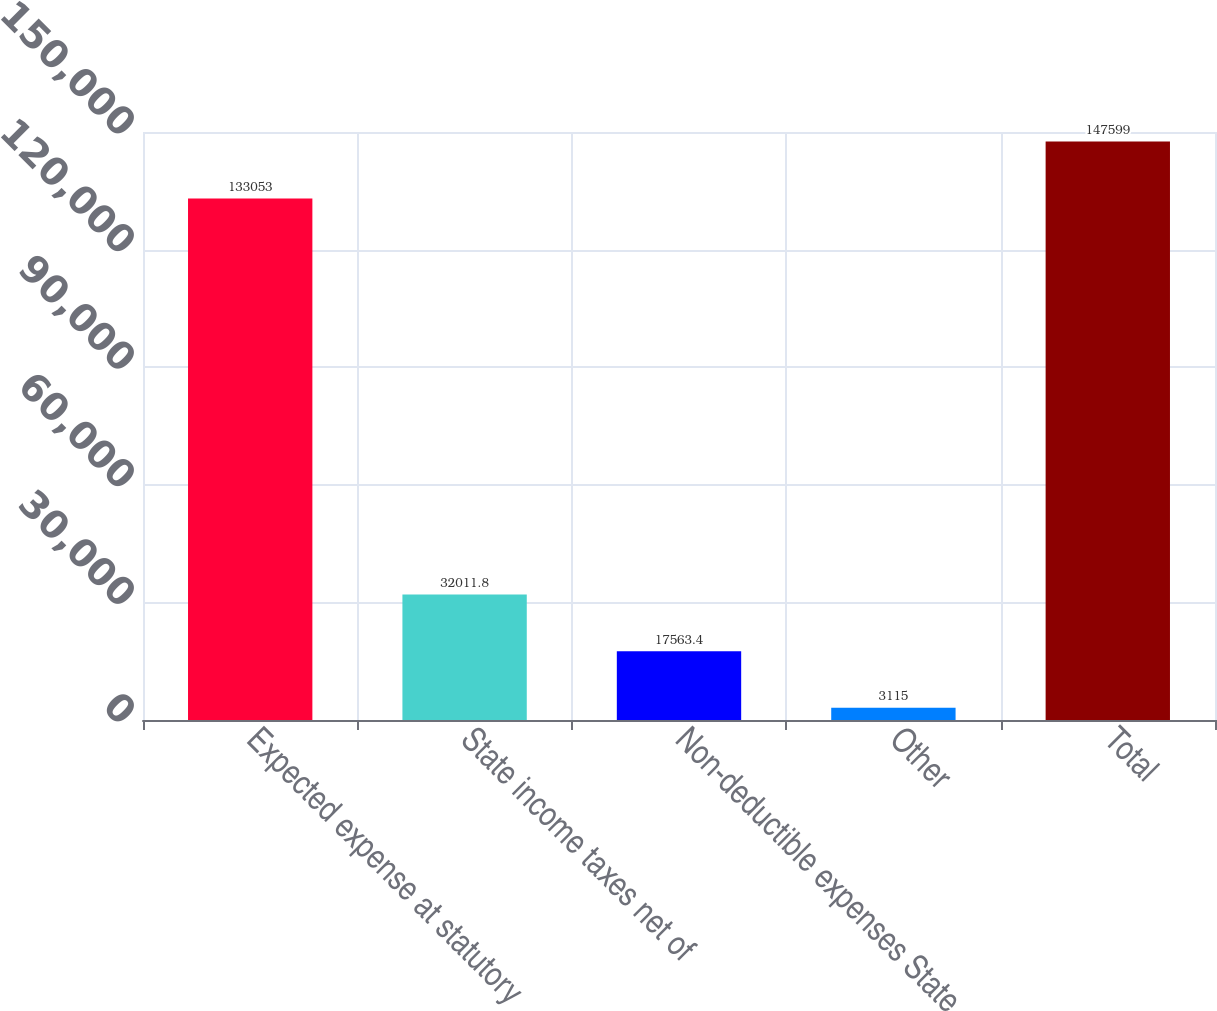<chart> <loc_0><loc_0><loc_500><loc_500><bar_chart><fcel>Expected expense at statutory<fcel>State income taxes net of<fcel>Non-deductible expenses State<fcel>Other<fcel>Total<nl><fcel>133053<fcel>32011.8<fcel>17563.4<fcel>3115<fcel>147599<nl></chart> 